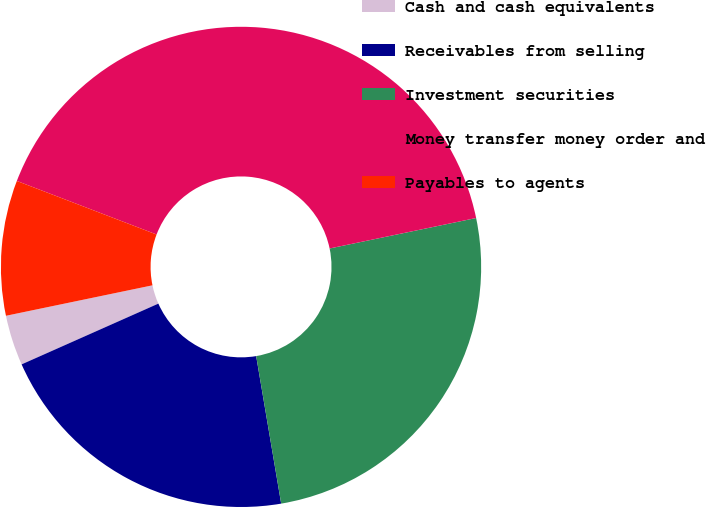Convert chart to OTSL. <chart><loc_0><loc_0><loc_500><loc_500><pie_chart><fcel>Cash and cash equivalents<fcel>Receivables from selling<fcel>Investment securities<fcel>Money transfer money order and<fcel>Payables to agents<nl><fcel>3.39%<fcel>21.02%<fcel>25.59%<fcel>40.91%<fcel>9.09%<nl></chart> 